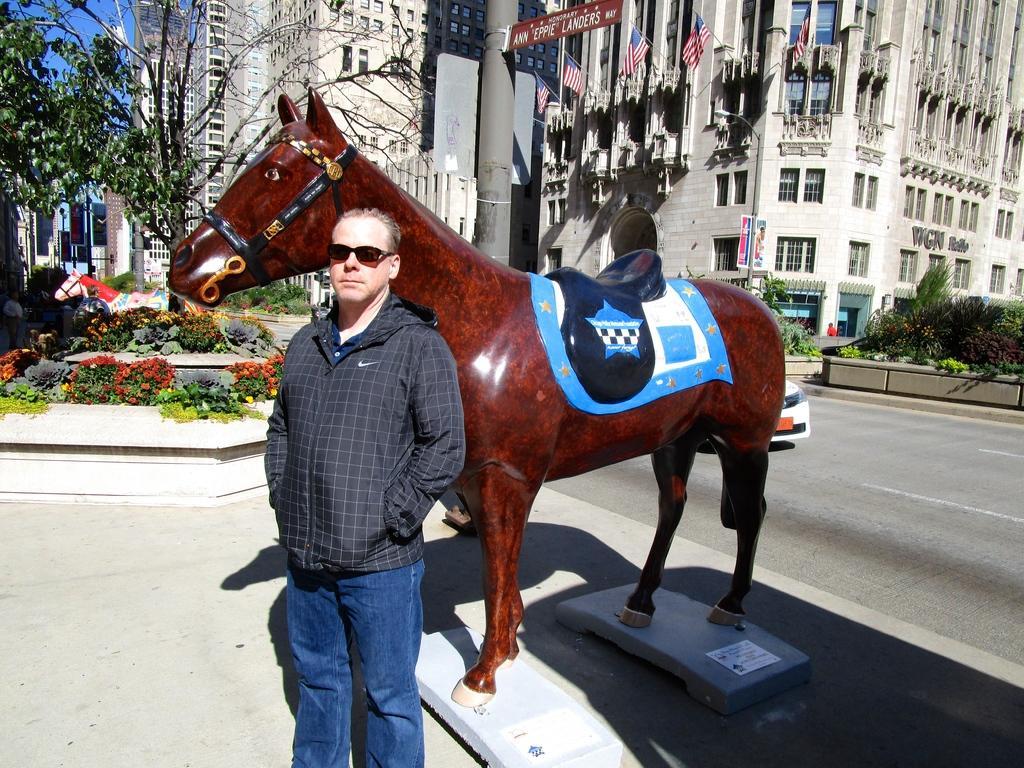How would you summarize this image in a sentence or two? In this image, this is the man standing. It looks like a statue of a horse. On the left side of the image, I can see the plants with the flowers and another statue of a horse. In the background, these are the buildings with the windows. I can see the flags hanging to the poles. On the right side of the image, I think these are the plants and bushes. It looks like a car, which is behind the statue of a horse. 